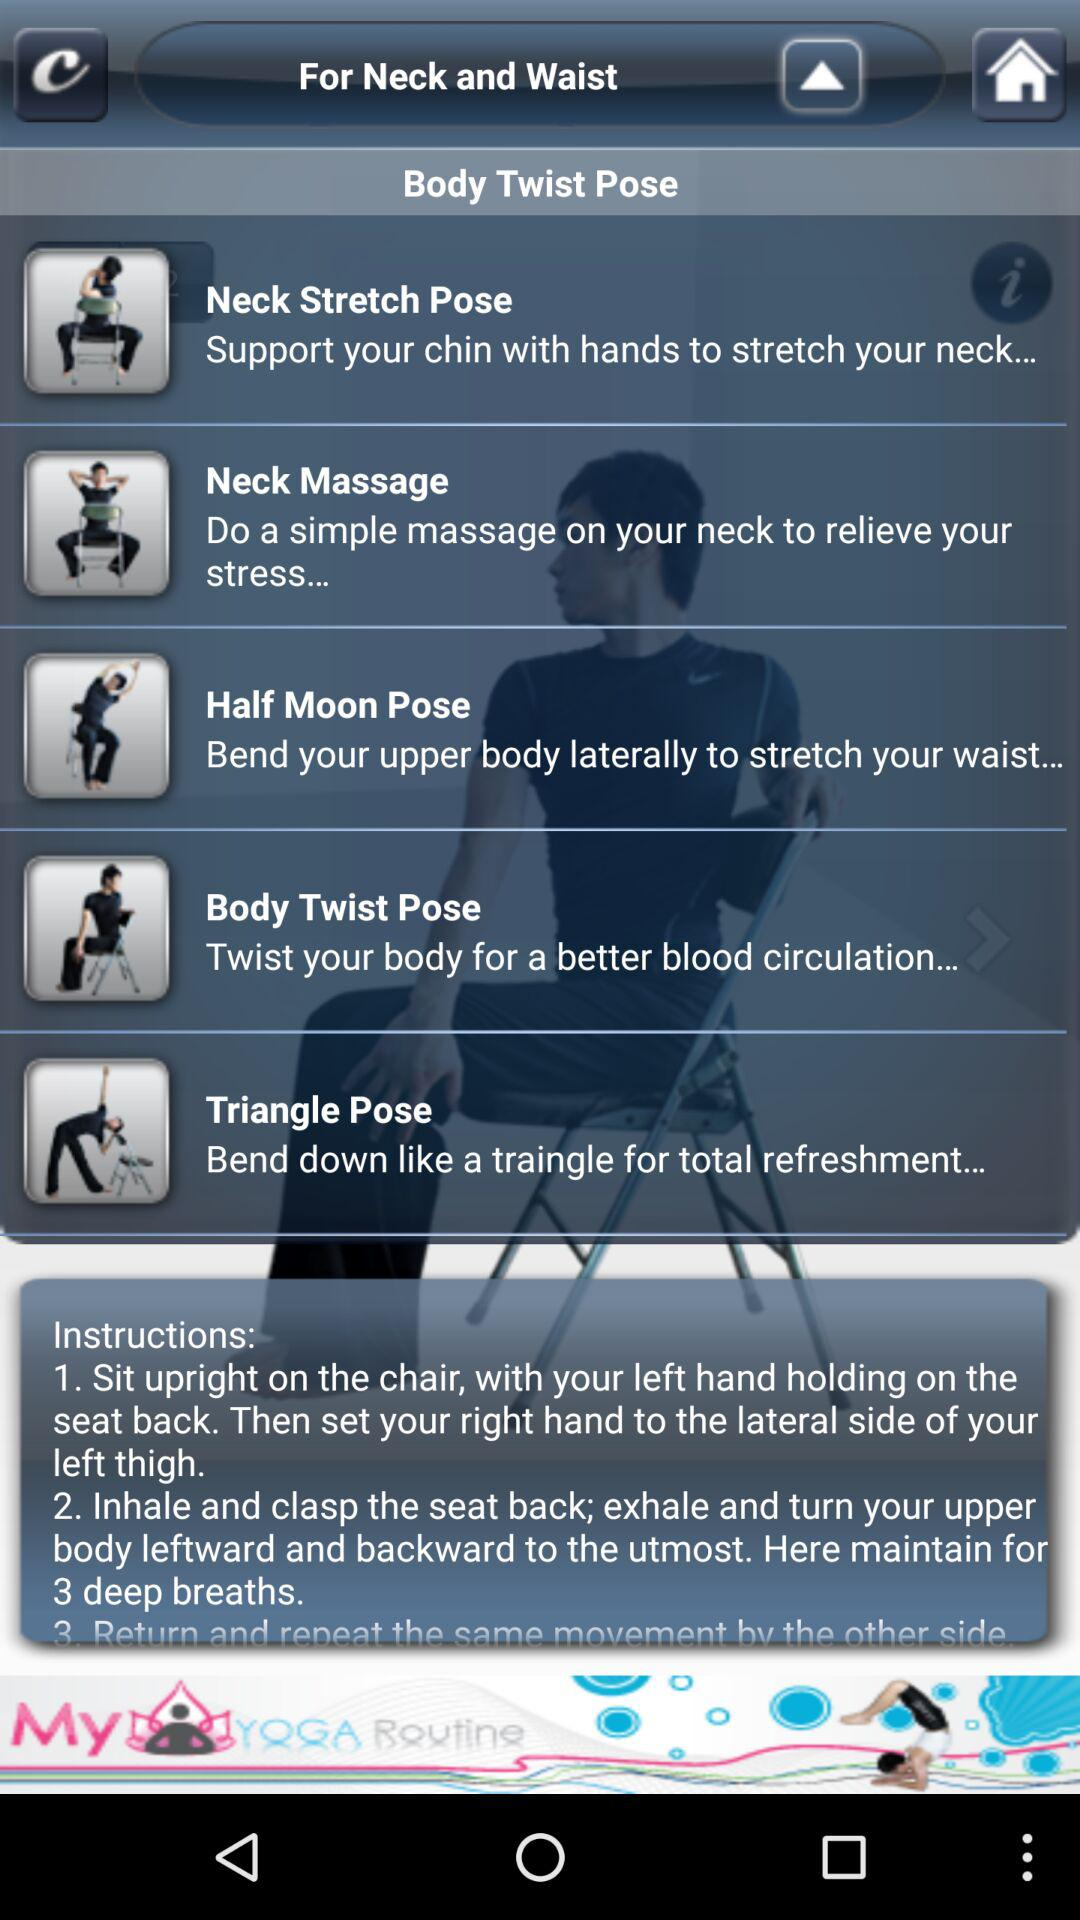Which pose is suitable for stretching the waist? The pose that is suitable for stretching the waist is "Half Moon Pose". 